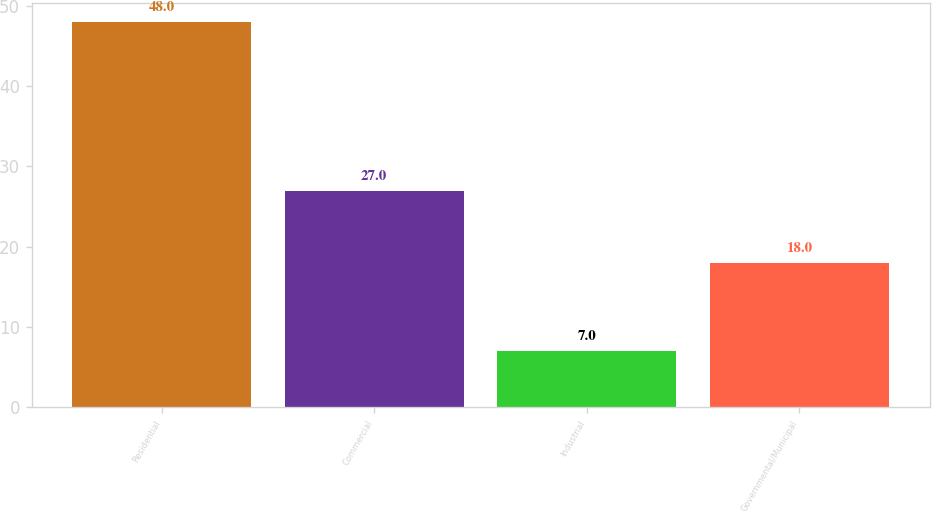Convert chart to OTSL. <chart><loc_0><loc_0><loc_500><loc_500><bar_chart><fcel>Residential<fcel>Commercial<fcel>Industrial<fcel>Governmental/Municipal<nl><fcel>48<fcel>27<fcel>7<fcel>18<nl></chart> 